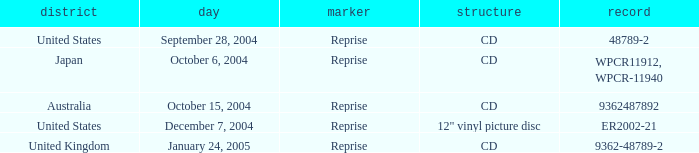Name the label for january 24, 2005 Reprise. Give me the full table as a dictionary. {'header': ['district', 'day', 'marker', 'structure', 'record'], 'rows': [['United States', 'September 28, 2004', 'Reprise', 'CD', '48789-2'], ['Japan', 'October 6, 2004', 'Reprise', 'CD', 'WPCR11912, WPCR-11940'], ['Australia', 'October 15, 2004', 'Reprise', 'CD', '9362487892'], ['United States', 'December 7, 2004', 'Reprise', '12" vinyl picture disc', 'ER2002-21'], ['United Kingdom', 'January 24, 2005', 'Reprise', 'CD', '9362-48789-2']]} 